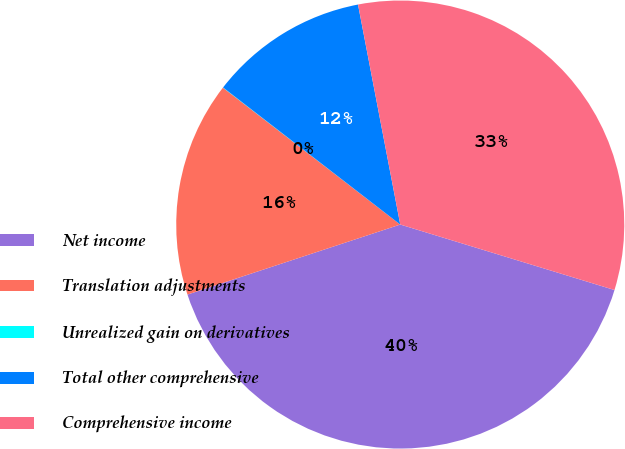Convert chart. <chart><loc_0><loc_0><loc_500><loc_500><pie_chart><fcel>Net income<fcel>Translation adjustments<fcel>Unrealized gain on derivatives<fcel>Total other comprehensive<fcel>Comprehensive income<nl><fcel>40.22%<fcel>15.52%<fcel>0.02%<fcel>11.5%<fcel>32.74%<nl></chart> 